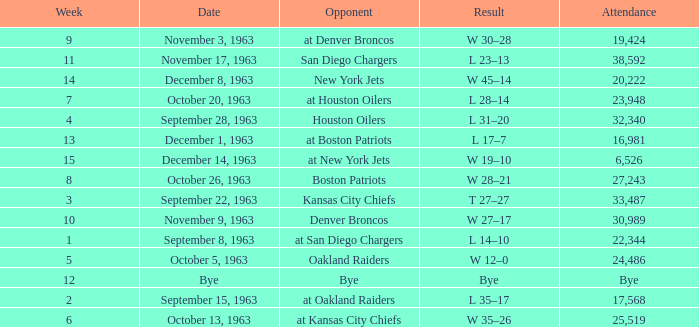Which Result has a Week smaller than 11, and Attendance of 17,568? L 35–17. 